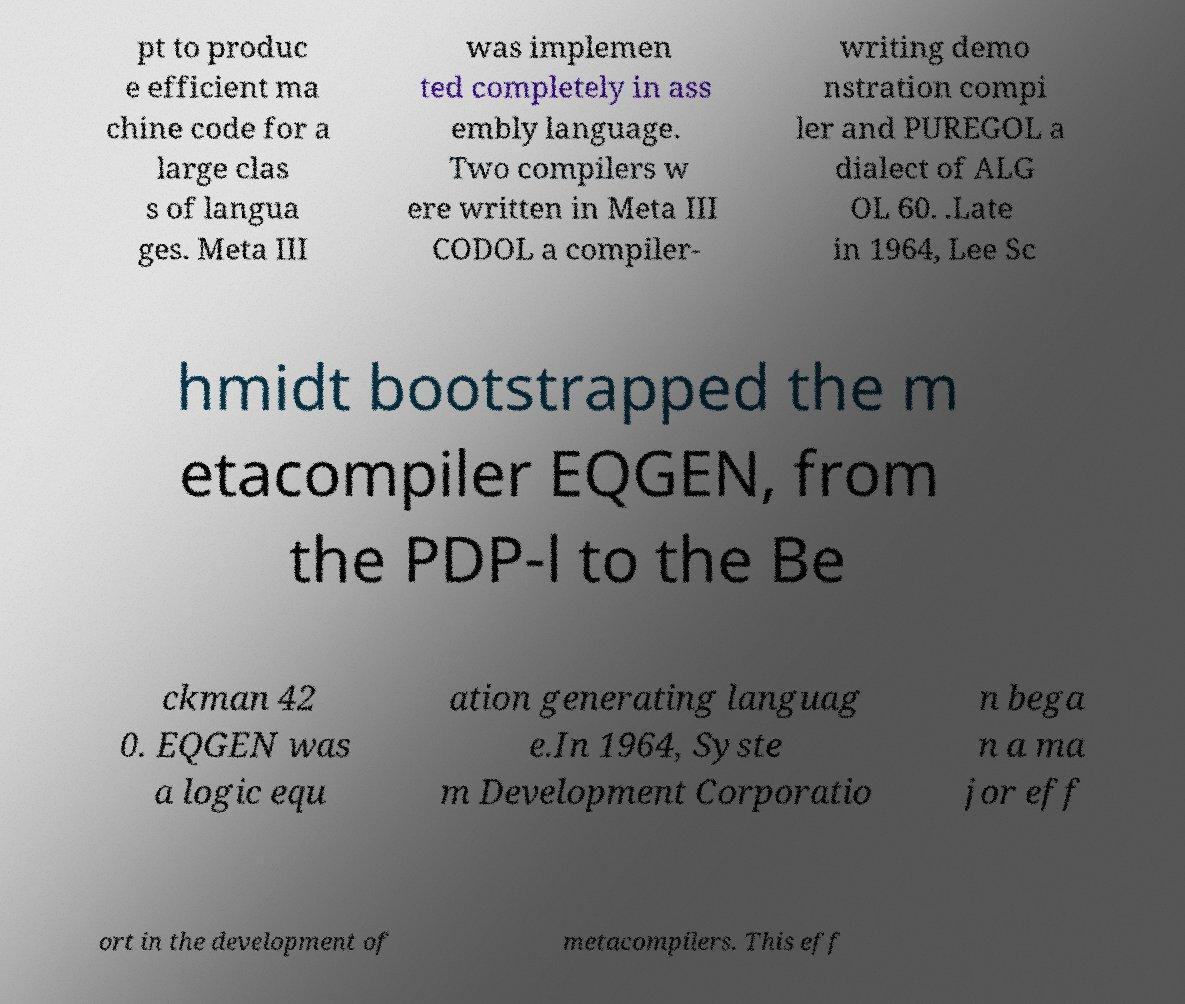I need the written content from this picture converted into text. Can you do that? pt to produc e efficient ma chine code for a large clas s of langua ges. Meta III was implemen ted completely in ass embly language. Two compilers w ere written in Meta III CODOL a compiler- writing demo nstration compi ler and PUREGOL a dialect of ALG OL 60. .Late in 1964, Lee Sc hmidt bootstrapped the m etacompiler EQGEN, from the PDP-l to the Be ckman 42 0. EQGEN was a logic equ ation generating languag e.In 1964, Syste m Development Corporatio n bega n a ma jor eff ort in the development of metacompilers. This eff 